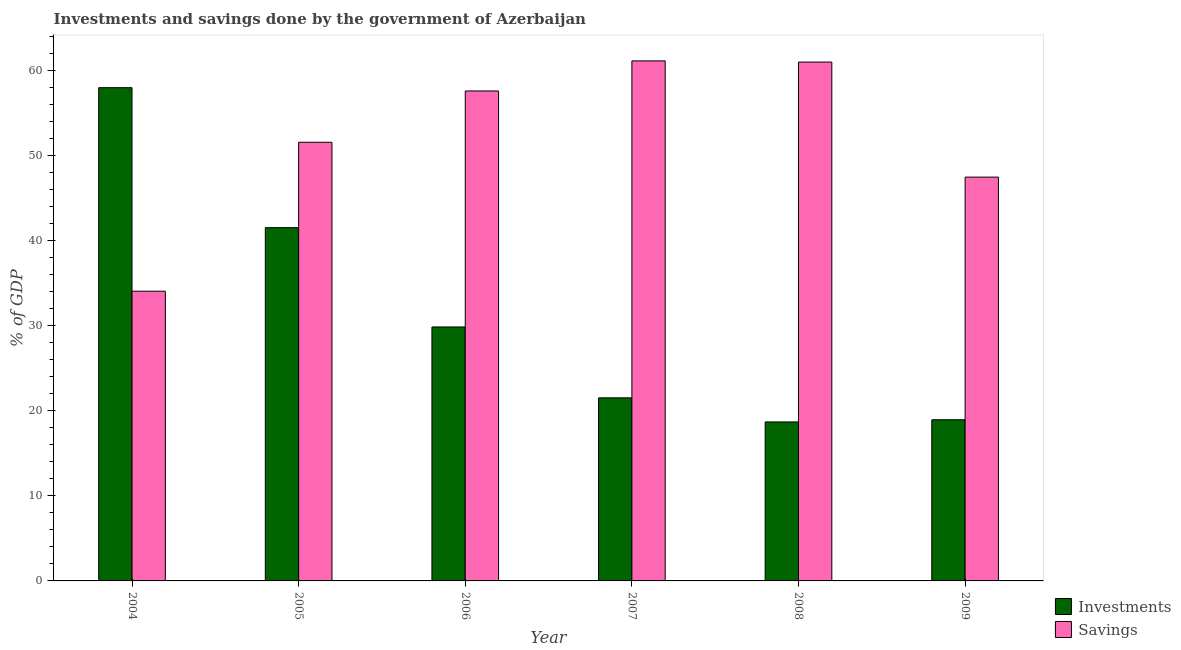How many different coloured bars are there?
Your answer should be compact. 2. How many groups of bars are there?
Your answer should be compact. 6. Are the number of bars per tick equal to the number of legend labels?
Offer a terse response. Yes. Are the number of bars on each tick of the X-axis equal?
Make the answer very short. Yes. How many bars are there on the 4th tick from the left?
Your response must be concise. 2. What is the label of the 6th group of bars from the left?
Your answer should be very brief. 2009. What is the savings of government in 2007?
Your answer should be very brief. 61.14. Across all years, what is the maximum investments of government?
Offer a terse response. 57.99. Across all years, what is the minimum savings of government?
Give a very brief answer. 34.06. In which year was the savings of government maximum?
Provide a short and direct response. 2007. What is the total savings of government in the graph?
Your response must be concise. 312.86. What is the difference between the investments of government in 2006 and that in 2007?
Make the answer very short. 8.33. What is the difference between the investments of government in 2009 and the savings of government in 2007?
Give a very brief answer. -2.58. What is the average investments of government per year?
Offer a very short reply. 31.43. In how many years, is the investments of government greater than 6 %?
Provide a short and direct response. 6. What is the ratio of the savings of government in 2008 to that in 2009?
Give a very brief answer. 1.28. Is the difference between the investments of government in 2004 and 2009 greater than the difference between the savings of government in 2004 and 2009?
Offer a terse response. No. What is the difference between the highest and the second highest investments of government?
Give a very brief answer. 16.46. What is the difference between the highest and the lowest investments of government?
Your answer should be compact. 39.3. Is the sum of the investments of government in 2007 and 2009 greater than the maximum savings of government across all years?
Provide a short and direct response. No. What does the 1st bar from the left in 2008 represents?
Your answer should be very brief. Investments. What does the 1st bar from the right in 2007 represents?
Provide a succinct answer. Savings. How many bars are there?
Provide a short and direct response. 12. Are all the bars in the graph horizontal?
Keep it short and to the point. No. Does the graph contain any zero values?
Give a very brief answer. No. Where does the legend appear in the graph?
Ensure brevity in your answer.  Bottom right. What is the title of the graph?
Your response must be concise. Investments and savings done by the government of Azerbaijan. What is the label or title of the Y-axis?
Your answer should be very brief. % of GDP. What is the % of GDP of Investments in 2004?
Offer a terse response. 57.99. What is the % of GDP in Savings in 2004?
Offer a terse response. 34.06. What is the % of GDP of Investments in 2005?
Your answer should be very brief. 41.53. What is the % of GDP in Savings in 2005?
Your response must be concise. 51.57. What is the % of GDP in Investments in 2006?
Give a very brief answer. 29.86. What is the % of GDP of Savings in 2006?
Make the answer very short. 57.61. What is the % of GDP of Investments in 2007?
Provide a short and direct response. 21.53. What is the % of GDP in Savings in 2007?
Provide a short and direct response. 61.14. What is the % of GDP in Investments in 2008?
Your answer should be very brief. 18.69. What is the % of GDP of Savings in 2008?
Make the answer very short. 61. What is the % of GDP of Investments in 2009?
Your answer should be compact. 18.95. What is the % of GDP in Savings in 2009?
Your response must be concise. 47.48. Across all years, what is the maximum % of GDP in Investments?
Provide a short and direct response. 57.99. Across all years, what is the maximum % of GDP in Savings?
Offer a very short reply. 61.14. Across all years, what is the minimum % of GDP in Investments?
Offer a very short reply. 18.69. Across all years, what is the minimum % of GDP of Savings?
Your answer should be very brief. 34.06. What is the total % of GDP in Investments in the graph?
Your answer should be compact. 188.55. What is the total % of GDP of Savings in the graph?
Your answer should be very brief. 312.86. What is the difference between the % of GDP of Investments in 2004 and that in 2005?
Make the answer very short. 16.46. What is the difference between the % of GDP in Savings in 2004 and that in 2005?
Provide a succinct answer. -17.51. What is the difference between the % of GDP in Investments in 2004 and that in 2006?
Give a very brief answer. 28.13. What is the difference between the % of GDP in Savings in 2004 and that in 2006?
Make the answer very short. -23.54. What is the difference between the % of GDP of Investments in 2004 and that in 2007?
Your answer should be very brief. 36.47. What is the difference between the % of GDP of Savings in 2004 and that in 2007?
Make the answer very short. -27.08. What is the difference between the % of GDP in Investments in 2004 and that in 2008?
Provide a succinct answer. 39.3. What is the difference between the % of GDP in Savings in 2004 and that in 2008?
Offer a very short reply. -26.94. What is the difference between the % of GDP of Investments in 2004 and that in 2009?
Give a very brief answer. 39.04. What is the difference between the % of GDP in Savings in 2004 and that in 2009?
Your answer should be very brief. -13.41. What is the difference between the % of GDP of Investments in 2005 and that in 2006?
Give a very brief answer. 11.68. What is the difference between the % of GDP in Savings in 2005 and that in 2006?
Your response must be concise. -6.03. What is the difference between the % of GDP of Investments in 2005 and that in 2007?
Ensure brevity in your answer.  20.01. What is the difference between the % of GDP of Savings in 2005 and that in 2007?
Offer a very short reply. -9.57. What is the difference between the % of GDP of Investments in 2005 and that in 2008?
Your answer should be compact. 22.84. What is the difference between the % of GDP in Savings in 2005 and that in 2008?
Ensure brevity in your answer.  -9.43. What is the difference between the % of GDP of Investments in 2005 and that in 2009?
Provide a succinct answer. 22.59. What is the difference between the % of GDP in Savings in 2005 and that in 2009?
Give a very brief answer. 4.1. What is the difference between the % of GDP of Investments in 2006 and that in 2007?
Provide a short and direct response. 8.33. What is the difference between the % of GDP of Savings in 2006 and that in 2007?
Your answer should be very brief. -3.54. What is the difference between the % of GDP in Investments in 2006 and that in 2008?
Make the answer very short. 11.17. What is the difference between the % of GDP of Savings in 2006 and that in 2008?
Keep it short and to the point. -3.4. What is the difference between the % of GDP of Investments in 2006 and that in 2009?
Your answer should be compact. 10.91. What is the difference between the % of GDP in Savings in 2006 and that in 2009?
Your answer should be very brief. 10.13. What is the difference between the % of GDP in Investments in 2007 and that in 2008?
Offer a very short reply. 2.83. What is the difference between the % of GDP of Savings in 2007 and that in 2008?
Your response must be concise. 0.14. What is the difference between the % of GDP in Investments in 2007 and that in 2009?
Provide a succinct answer. 2.58. What is the difference between the % of GDP of Savings in 2007 and that in 2009?
Your answer should be very brief. 13.67. What is the difference between the % of GDP in Investments in 2008 and that in 2009?
Your answer should be very brief. -0.26. What is the difference between the % of GDP of Savings in 2008 and that in 2009?
Make the answer very short. 13.53. What is the difference between the % of GDP of Investments in 2004 and the % of GDP of Savings in 2005?
Provide a succinct answer. 6.42. What is the difference between the % of GDP in Investments in 2004 and the % of GDP in Savings in 2006?
Provide a succinct answer. 0.38. What is the difference between the % of GDP of Investments in 2004 and the % of GDP of Savings in 2007?
Your answer should be compact. -3.15. What is the difference between the % of GDP of Investments in 2004 and the % of GDP of Savings in 2008?
Your answer should be very brief. -3.01. What is the difference between the % of GDP of Investments in 2004 and the % of GDP of Savings in 2009?
Your answer should be compact. 10.51. What is the difference between the % of GDP of Investments in 2005 and the % of GDP of Savings in 2006?
Your answer should be very brief. -16.07. What is the difference between the % of GDP of Investments in 2005 and the % of GDP of Savings in 2007?
Give a very brief answer. -19.61. What is the difference between the % of GDP in Investments in 2005 and the % of GDP in Savings in 2008?
Provide a short and direct response. -19.47. What is the difference between the % of GDP in Investments in 2005 and the % of GDP in Savings in 2009?
Provide a short and direct response. -5.94. What is the difference between the % of GDP of Investments in 2006 and the % of GDP of Savings in 2007?
Make the answer very short. -31.28. What is the difference between the % of GDP of Investments in 2006 and the % of GDP of Savings in 2008?
Offer a very short reply. -31.14. What is the difference between the % of GDP in Investments in 2006 and the % of GDP in Savings in 2009?
Provide a short and direct response. -17.62. What is the difference between the % of GDP of Investments in 2007 and the % of GDP of Savings in 2008?
Make the answer very short. -39.48. What is the difference between the % of GDP of Investments in 2007 and the % of GDP of Savings in 2009?
Make the answer very short. -25.95. What is the difference between the % of GDP in Investments in 2008 and the % of GDP in Savings in 2009?
Offer a terse response. -28.78. What is the average % of GDP of Investments per year?
Provide a succinct answer. 31.43. What is the average % of GDP in Savings per year?
Provide a short and direct response. 52.14. In the year 2004, what is the difference between the % of GDP in Investments and % of GDP in Savings?
Make the answer very short. 23.93. In the year 2005, what is the difference between the % of GDP of Investments and % of GDP of Savings?
Ensure brevity in your answer.  -10.04. In the year 2006, what is the difference between the % of GDP in Investments and % of GDP in Savings?
Provide a succinct answer. -27.75. In the year 2007, what is the difference between the % of GDP in Investments and % of GDP in Savings?
Give a very brief answer. -39.62. In the year 2008, what is the difference between the % of GDP in Investments and % of GDP in Savings?
Ensure brevity in your answer.  -42.31. In the year 2009, what is the difference between the % of GDP of Investments and % of GDP of Savings?
Keep it short and to the point. -28.53. What is the ratio of the % of GDP in Investments in 2004 to that in 2005?
Your answer should be compact. 1.4. What is the ratio of the % of GDP of Savings in 2004 to that in 2005?
Provide a succinct answer. 0.66. What is the ratio of the % of GDP in Investments in 2004 to that in 2006?
Ensure brevity in your answer.  1.94. What is the ratio of the % of GDP in Savings in 2004 to that in 2006?
Ensure brevity in your answer.  0.59. What is the ratio of the % of GDP of Investments in 2004 to that in 2007?
Offer a very short reply. 2.69. What is the ratio of the % of GDP of Savings in 2004 to that in 2007?
Offer a very short reply. 0.56. What is the ratio of the % of GDP of Investments in 2004 to that in 2008?
Provide a short and direct response. 3.1. What is the ratio of the % of GDP of Savings in 2004 to that in 2008?
Offer a very short reply. 0.56. What is the ratio of the % of GDP of Investments in 2004 to that in 2009?
Provide a succinct answer. 3.06. What is the ratio of the % of GDP of Savings in 2004 to that in 2009?
Make the answer very short. 0.72. What is the ratio of the % of GDP of Investments in 2005 to that in 2006?
Your answer should be compact. 1.39. What is the ratio of the % of GDP in Savings in 2005 to that in 2006?
Your response must be concise. 0.9. What is the ratio of the % of GDP in Investments in 2005 to that in 2007?
Give a very brief answer. 1.93. What is the ratio of the % of GDP of Savings in 2005 to that in 2007?
Provide a short and direct response. 0.84. What is the ratio of the % of GDP in Investments in 2005 to that in 2008?
Your answer should be very brief. 2.22. What is the ratio of the % of GDP in Savings in 2005 to that in 2008?
Make the answer very short. 0.85. What is the ratio of the % of GDP of Investments in 2005 to that in 2009?
Make the answer very short. 2.19. What is the ratio of the % of GDP of Savings in 2005 to that in 2009?
Ensure brevity in your answer.  1.09. What is the ratio of the % of GDP in Investments in 2006 to that in 2007?
Provide a succinct answer. 1.39. What is the ratio of the % of GDP of Savings in 2006 to that in 2007?
Your answer should be compact. 0.94. What is the ratio of the % of GDP of Investments in 2006 to that in 2008?
Offer a terse response. 1.6. What is the ratio of the % of GDP of Savings in 2006 to that in 2008?
Your answer should be compact. 0.94. What is the ratio of the % of GDP of Investments in 2006 to that in 2009?
Provide a succinct answer. 1.58. What is the ratio of the % of GDP of Savings in 2006 to that in 2009?
Your answer should be compact. 1.21. What is the ratio of the % of GDP in Investments in 2007 to that in 2008?
Offer a very short reply. 1.15. What is the ratio of the % of GDP in Savings in 2007 to that in 2008?
Your answer should be very brief. 1. What is the ratio of the % of GDP in Investments in 2007 to that in 2009?
Keep it short and to the point. 1.14. What is the ratio of the % of GDP in Savings in 2007 to that in 2009?
Offer a terse response. 1.29. What is the ratio of the % of GDP of Investments in 2008 to that in 2009?
Your response must be concise. 0.99. What is the ratio of the % of GDP of Savings in 2008 to that in 2009?
Offer a very short reply. 1.28. What is the difference between the highest and the second highest % of GDP of Investments?
Your answer should be compact. 16.46. What is the difference between the highest and the second highest % of GDP of Savings?
Provide a short and direct response. 0.14. What is the difference between the highest and the lowest % of GDP in Investments?
Make the answer very short. 39.3. What is the difference between the highest and the lowest % of GDP in Savings?
Keep it short and to the point. 27.08. 